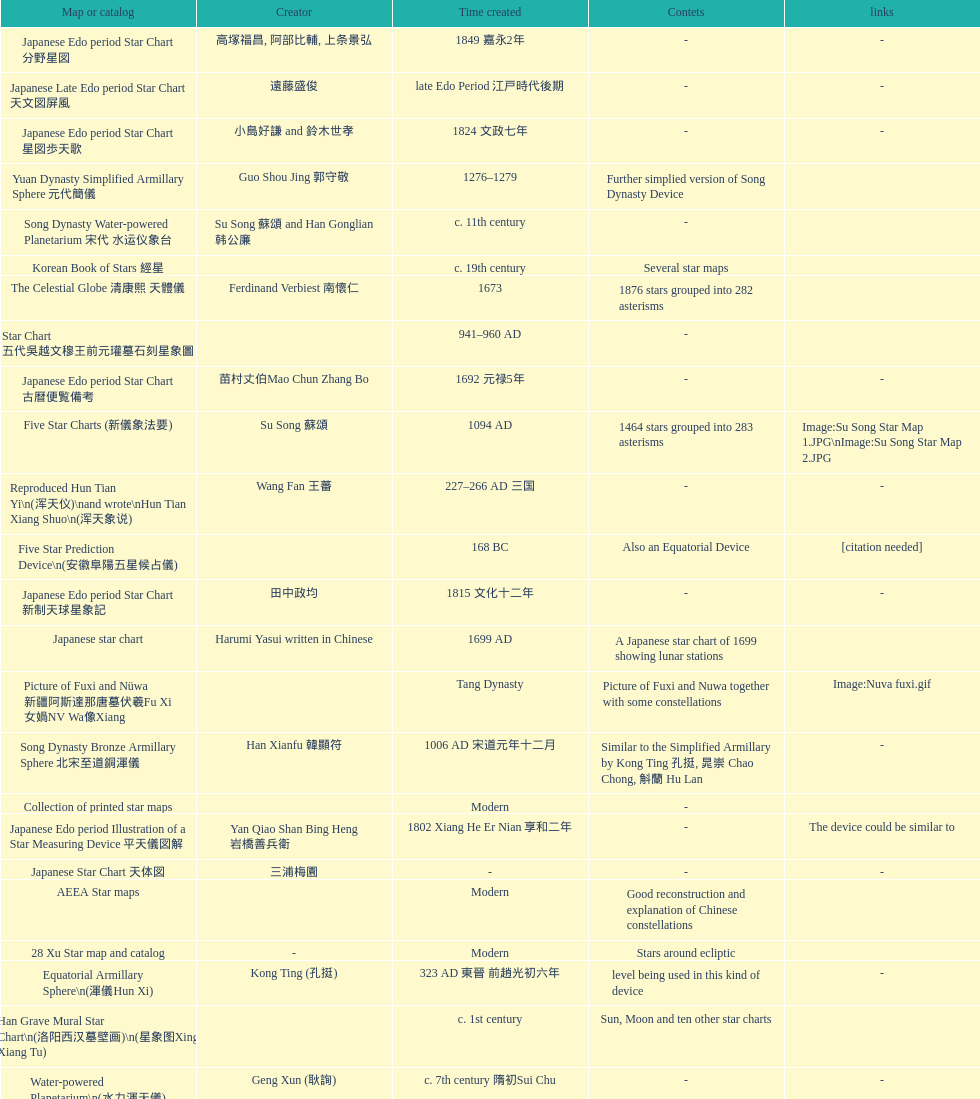Which was the first chinese star map known to have been created? M45 (伏羲星图Fuxixingtu). 